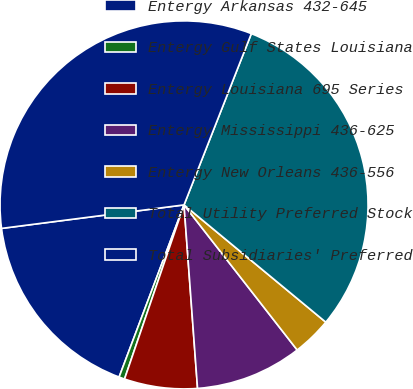<chart> <loc_0><loc_0><loc_500><loc_500><pie_chart><fcel>Entergy Arkansas 432-645<fcel>Entergy Gulf States Louisiana<fcel>Entergy Louisiana 695 Series<fcel>Entergy Mississippi 436-625<fcel>Entergy New Orleans 436-556<fcel>Total Utility Preferred Stock<fcel>Total Subsidiaries' Preferred<nl><fcel>17.22%<fcel>0.5%<fcel>6.41%<fcel>9.37%<fcel>3.46%<fcel>30.04%<fcel>33.0%<nl></chart> 